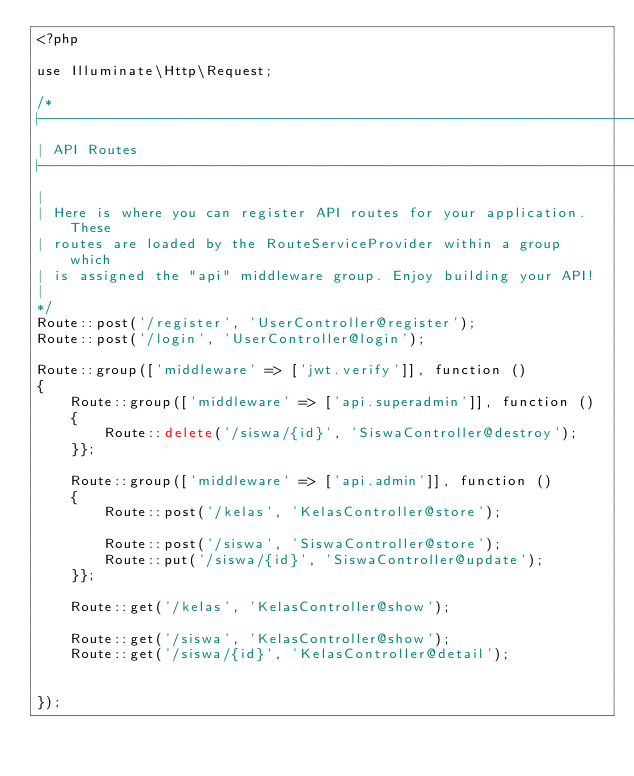<code> <loc_0><loc_0><loc_500><loc_500><_PHP_><?php

use Illuminate\Http\Request;

/*
|--------------------------------------------------------------------------
| API Routes
|--------------------------------------------------------------------------
|
| Here is where you can register API routes for your application. These
| routes are loaded by the RouteServiceProvider within a group which
| is assigned the "api" middleware group. Enjoy building your API!
|
*/
Route::post('/register', 'UserController@register');
Route::post('/login', 'UserController@login');

Route::group(['middleware' => ['jwt.verify']], function ()
{
	Route::group(['middleware' => ['api.superadmin']], function ()
	{
		Route::delete('/siswa/{id}', 'SiswaController@destroy');
	}};	

	Route::group(['middleware' => ['api.admin']], function ()
	{	
		Route::post('/kelas', 'KelasController@store');

		Route::post('/siswa', 'SiswaController@store');
		Route::put('/siswa/{id}', 'SiswaController@update');
	}};	

	Route::get('/kelas', 'KelasController@show');
	
	Route::get('/siswa', 'KelasController@show');
	Route::get('/siswa/{id}', 'KelasController@detail');
	
	
});</code> 